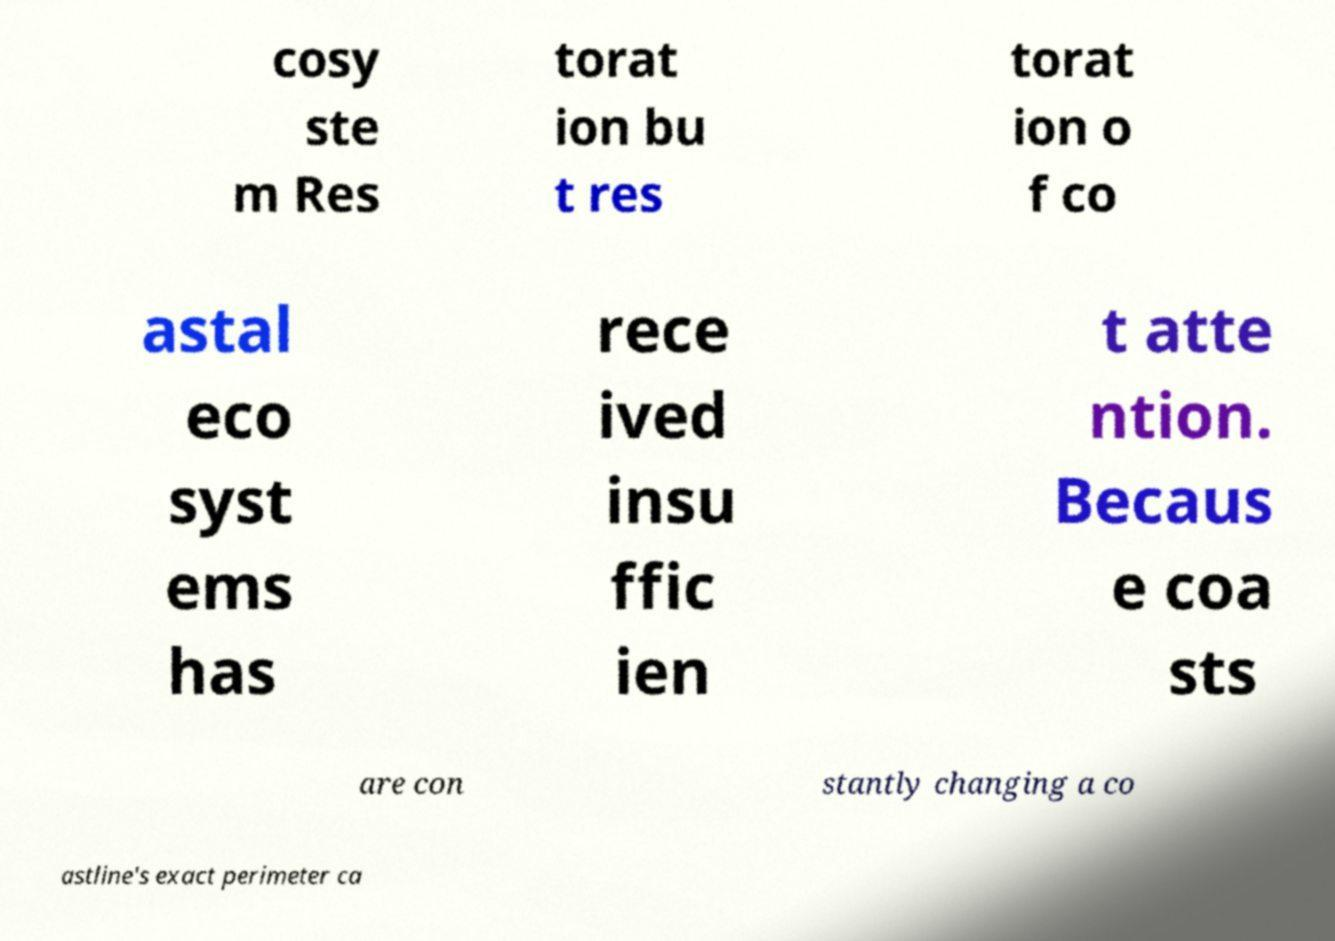Can you read and provide the text displayed in the image?This photo seems to have some interesting text. Can you extract and type it out for me? cosy ste m Res torat ion bu t res torat ion o f co astal eco syst ems has rece ived insu ffic ien t atte ntion. Becaus e coa sts are con stantly changing a co astline's exact perimeter ca 